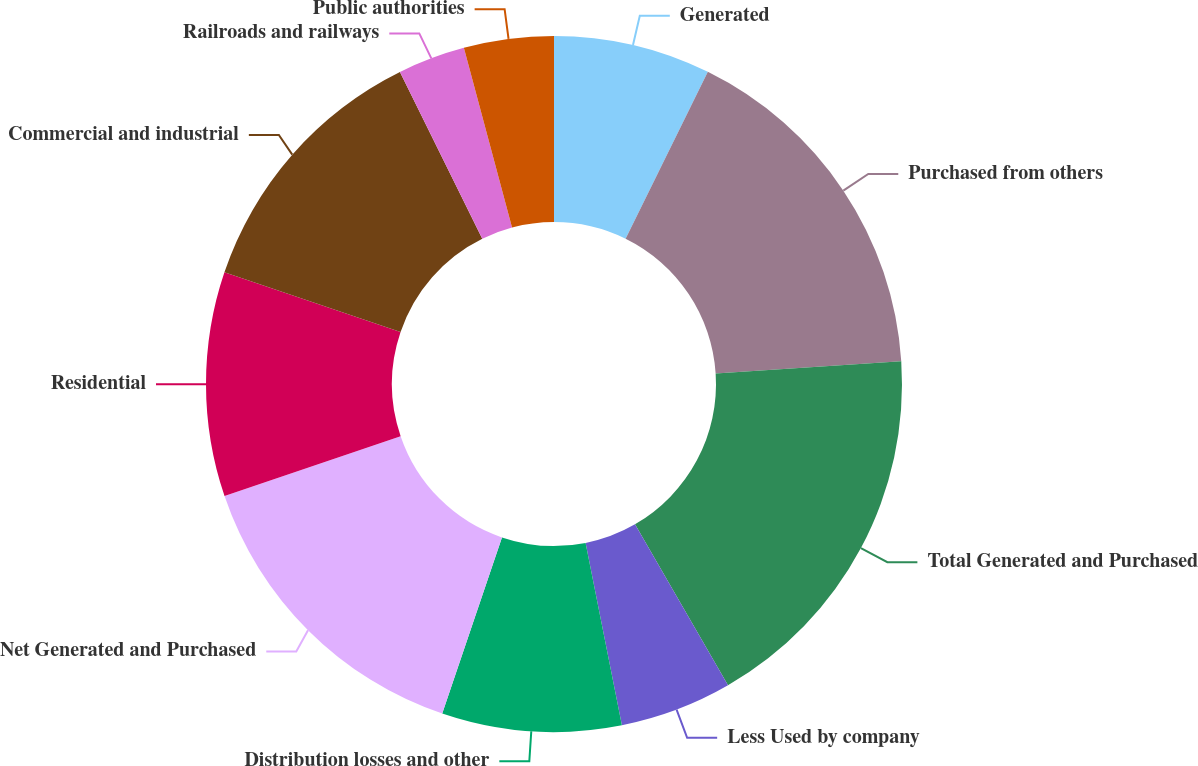Convert chart. <chart><loc_0><loc_0><loc_500><loc_500><pie_chart><fcel>Generated<fcel>Purchased from others<fcel>Total Generated and Purchased<fcel>Less Used by company<fcel>Distribution losses and other<fcel>Net Generated and Purchased<fcel>Residential<fcel>Commercial and industrial<fcel>Railroads and railways<fcel>Public authorities<nl><fcel>7.29%<fcel>16.67%<fcel>17.71%<fcel>5.21%<fcel>8.33%<fcel>14.58%<fcel>10.42%<fcel>12.5%<fcel>3.13%<fcel>4.17%<nl></chart> 